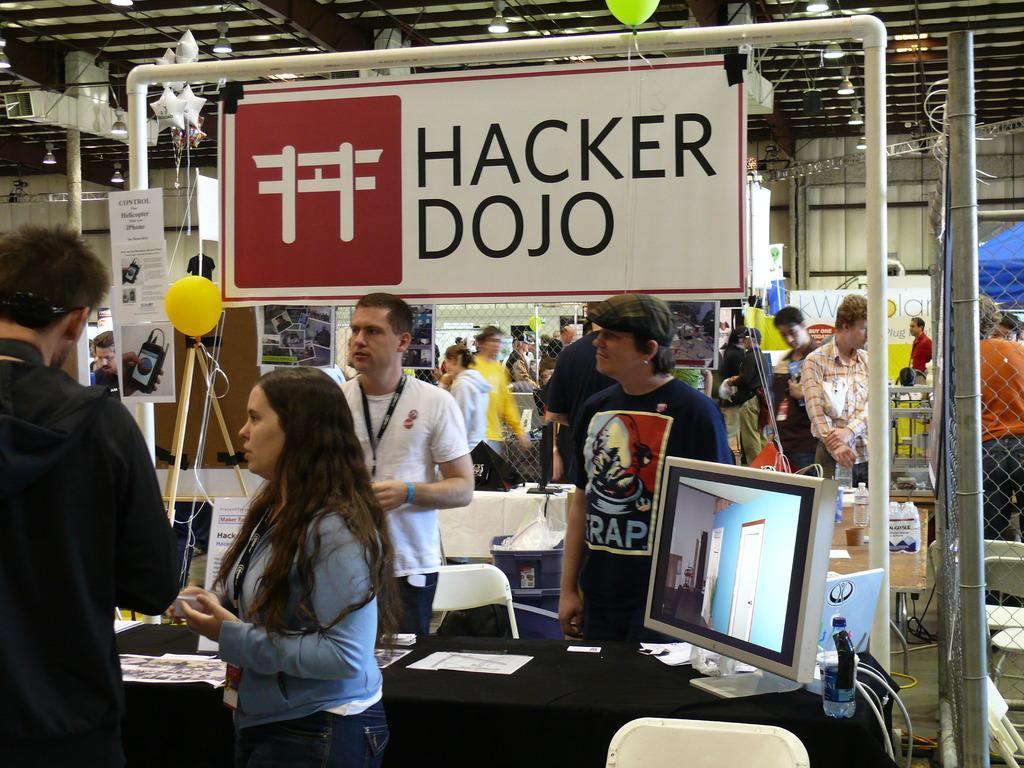Please provide a concise description of this image. There is a woman standing in the center and she is speaking. There are two people standing in the center. In the background we can see a six people. 